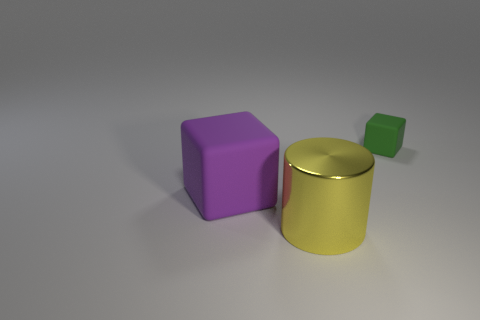Is there any other thing that has the same material as the large cylinder?
Provide a succinct answer. No. Is there any other thing that has the same shape as the yellow object?
Offer a very short reply. No. How many things are right of the yellow shiny cylinder and to the left of the yellow object?
Your answer should be very brief. 0. Are there the same number of small rubber cubes that are to the right of the large matte thing and tiny blocks in front of the small matte thing?
Offer a terse response. No. There is a matte block that is in front of the small green matte object; is it the same size as the matte cube that is to the right of the big cylinder?
Keep it short and to the point. No. The object that is in front of the green rubber thing and behind the large shiny cylinder is made of what material?
Offer a terse response. Rubber. Is the number of green matte cubes less than the number of blue cylinders?
Your answer should be very brief. No. How big is the rubber thing to the left of the yellow thing left of the green matte block?
Offer a terse response. Large. There is a rubber object to the left of the big object right of the matte cube in front of the small green matte object; what shape is it?
Your response must be concise. Cube. There is a thing that is made of the same material as the purple block; what color is it?
Your response must be concise. Green. 